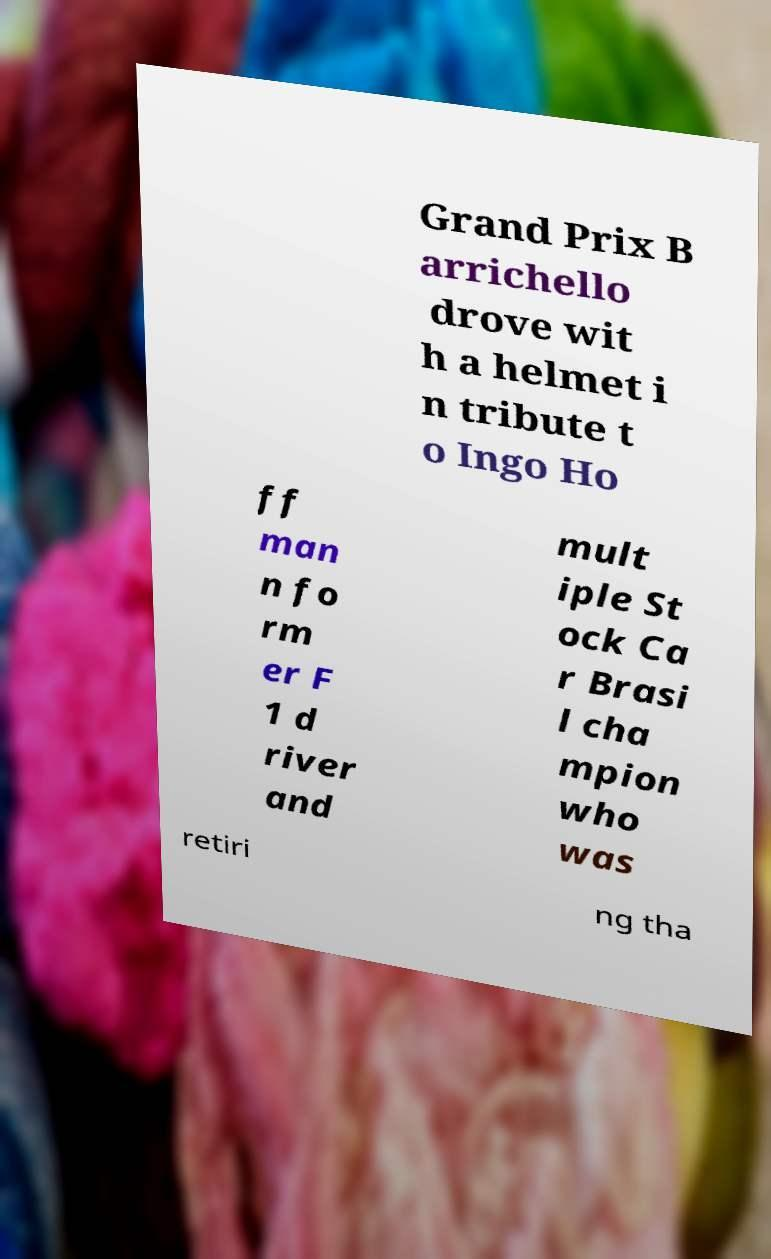For documentation purposes, I need the text within this image transcribed. Could you provide that? Grand Prix B arrichello drove wit h a helmet i n tribute t o Ingo Ho ff man n fo rm er F 1 d river and mult iple St ock Ca r Brasi l cha mpion who was retiri ng tha 